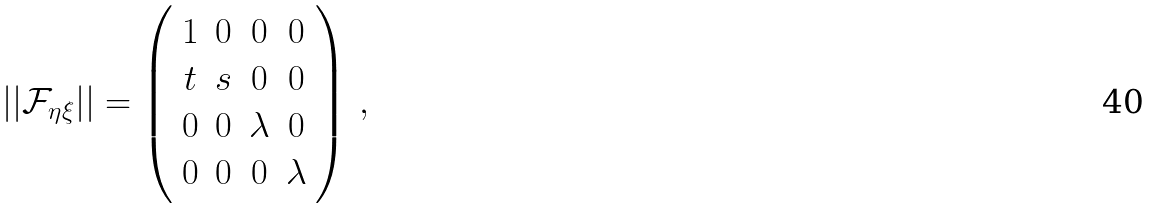Convert formula to latex. <formula><loc_0><loc_0><loc_500><loc_500>| | \mathcal { F } _ { \eta \xi } | | = \left ( \begin{array} { c c c c } 1 & 0 & 0 & 0 \\ t & s & 0 & 0 \\ 0 & 0 & \lambda & 0 \\ 0 & 0 & 0 & \lambda \end{array} \right ) \, ,</formula> 